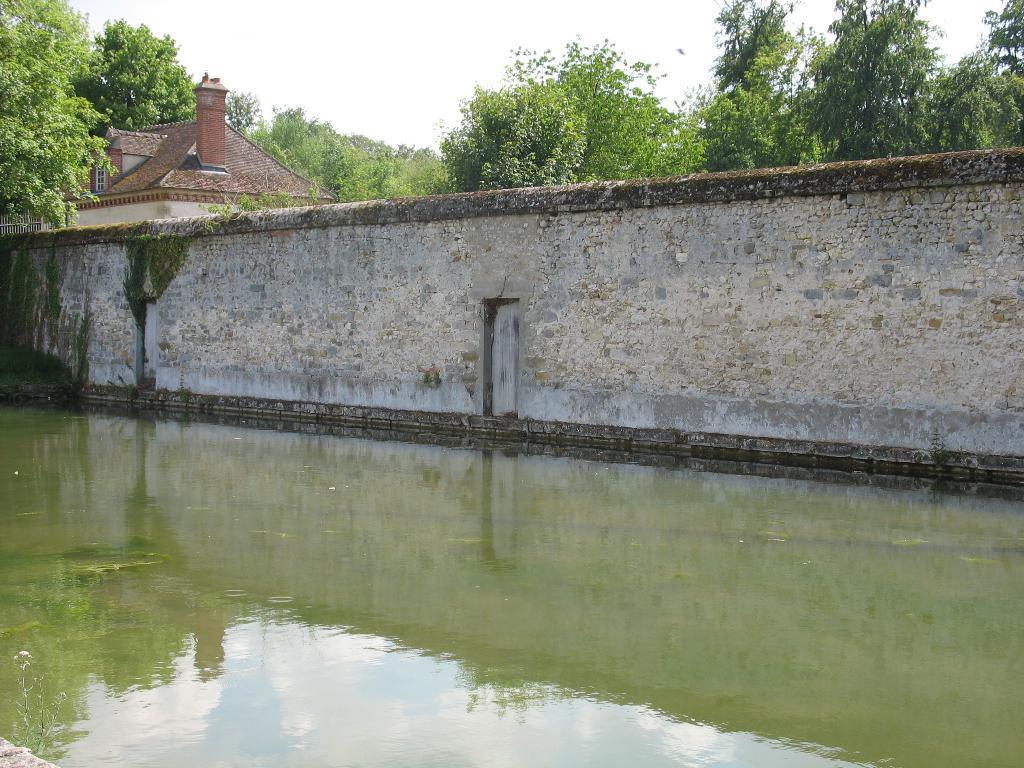Could you give a brief overview of what you see in this image? In the foreground I can see water, a wall fence, house and trees. On the top I can see the sky. This image is taken during a day. 